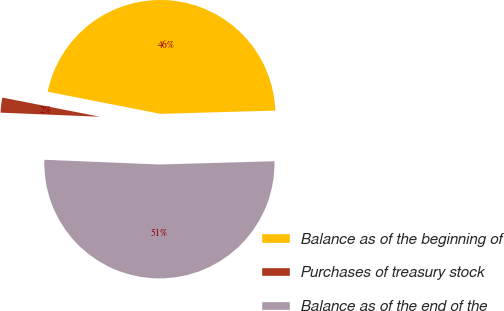<chart> <loc_0><loc_0><loc_500><loc_500><pie_chart><fcel>Balance as of the beginning of<fcel>Purchases of treasury stock<fcel>Balance as of the end of the<nl><fcel>46.46%<fcel>2.43%<fcel>51.11%<nl></chart> 